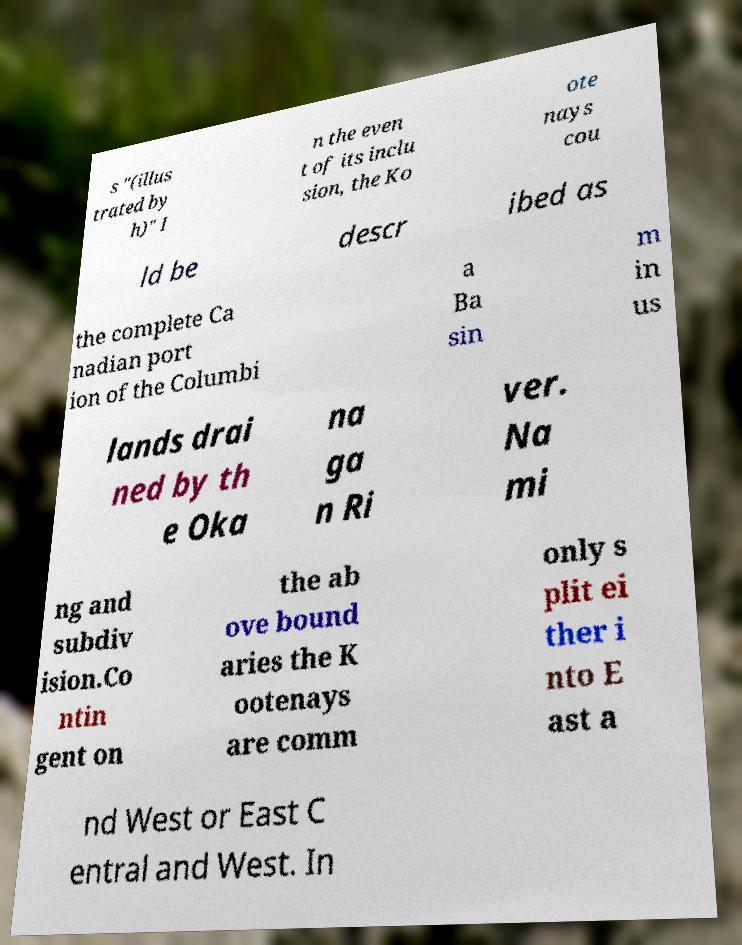Please identify and transcribe the text found in this image. s "(illus trated by h)" I n the even t of its inclu sion, the Ko ote nays cou ld be descr ibed as the complete Ca nadian port ion of the Columbi a Ba sin m in us lands drai ned by th e Oka na ga n Ri ver. Na mi ng and subdiv ision.Co ntin gent on the ab ove bound aries the K ootenays are comm only s plit ei ther i nto E ast a nd West or East C entral and West. In 